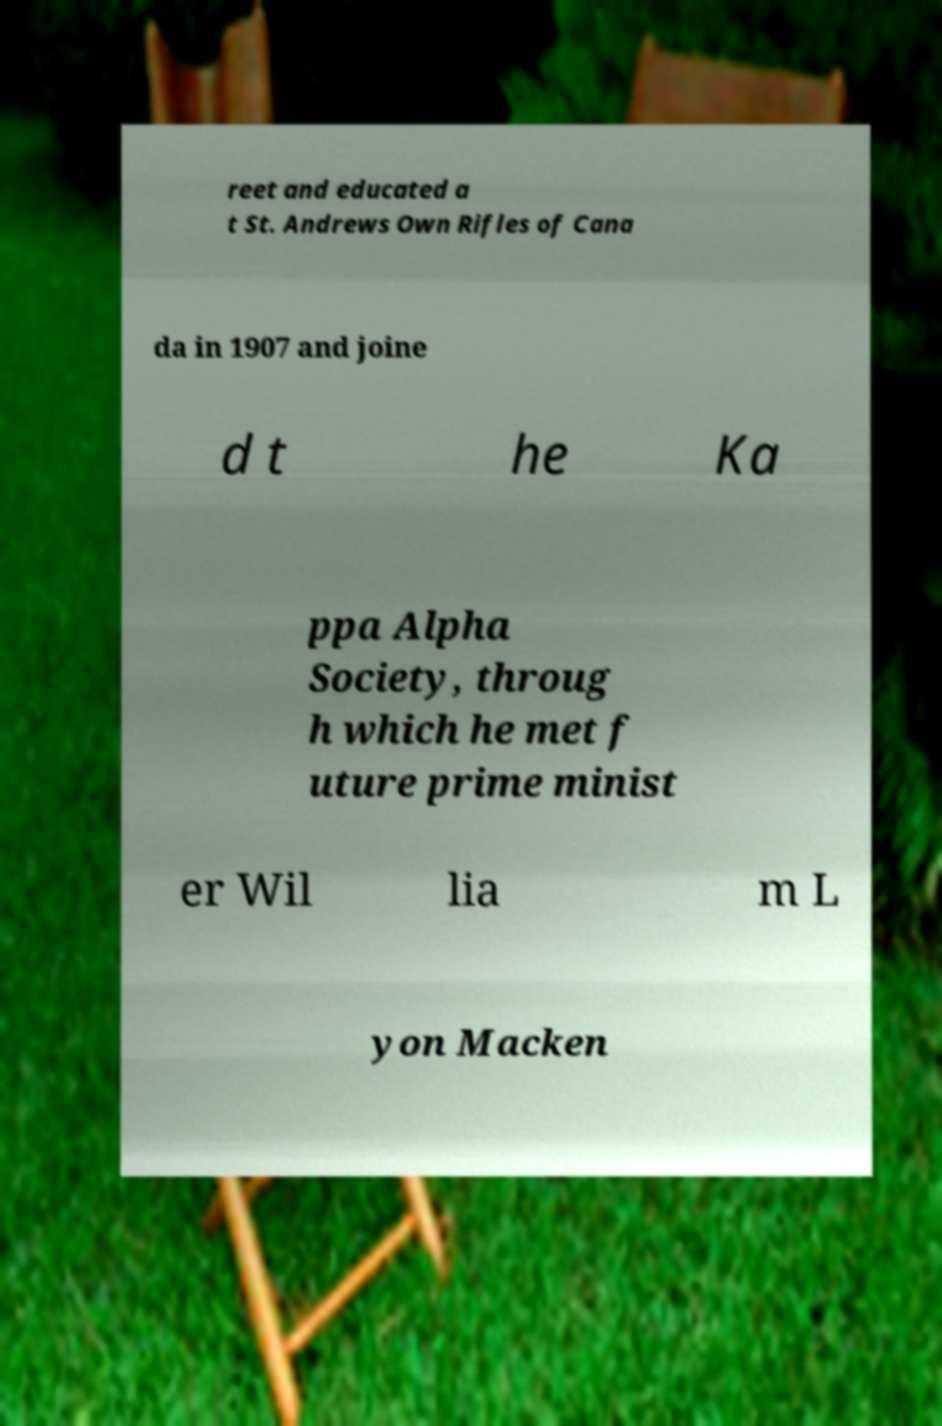What messages or text are displayed in this image? I need them in a readable, typed format. reet and educated a t St. Andrews Own Rifles of Cana da in 1907 and joine d t he Ka ppa Alpha Society, throug h which he met f uture prime minist er Wil lia m L yon Macken 